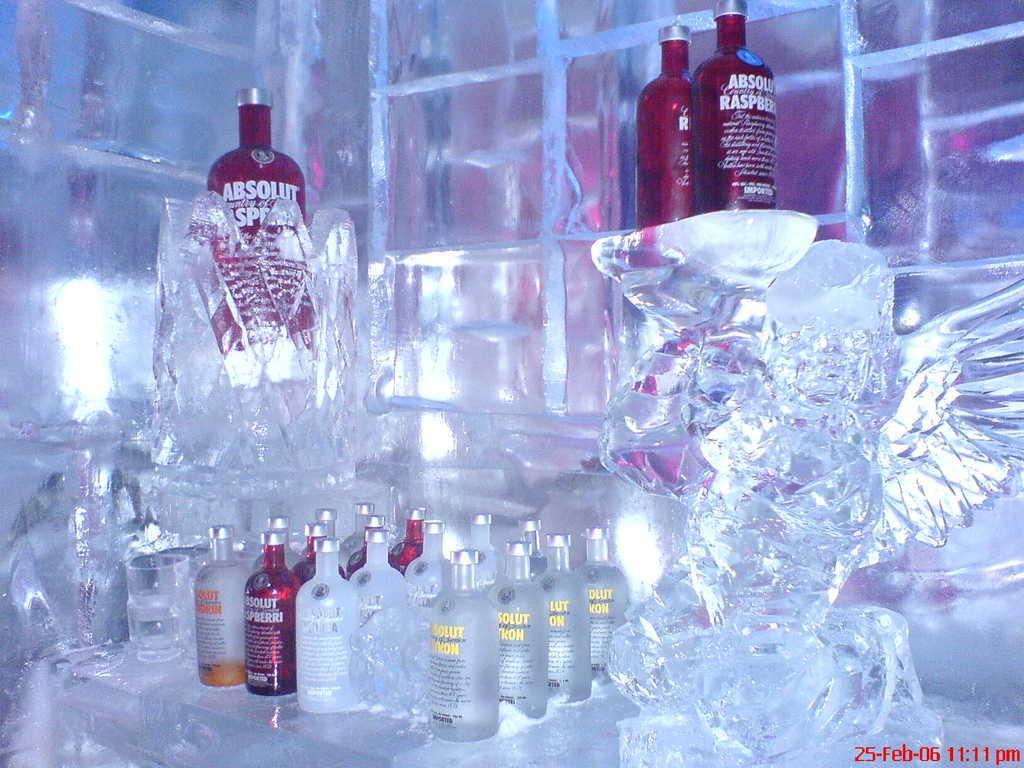Please provide a concise description of this image. In the picture there are many bottles present there is an ice present near the bottle. 